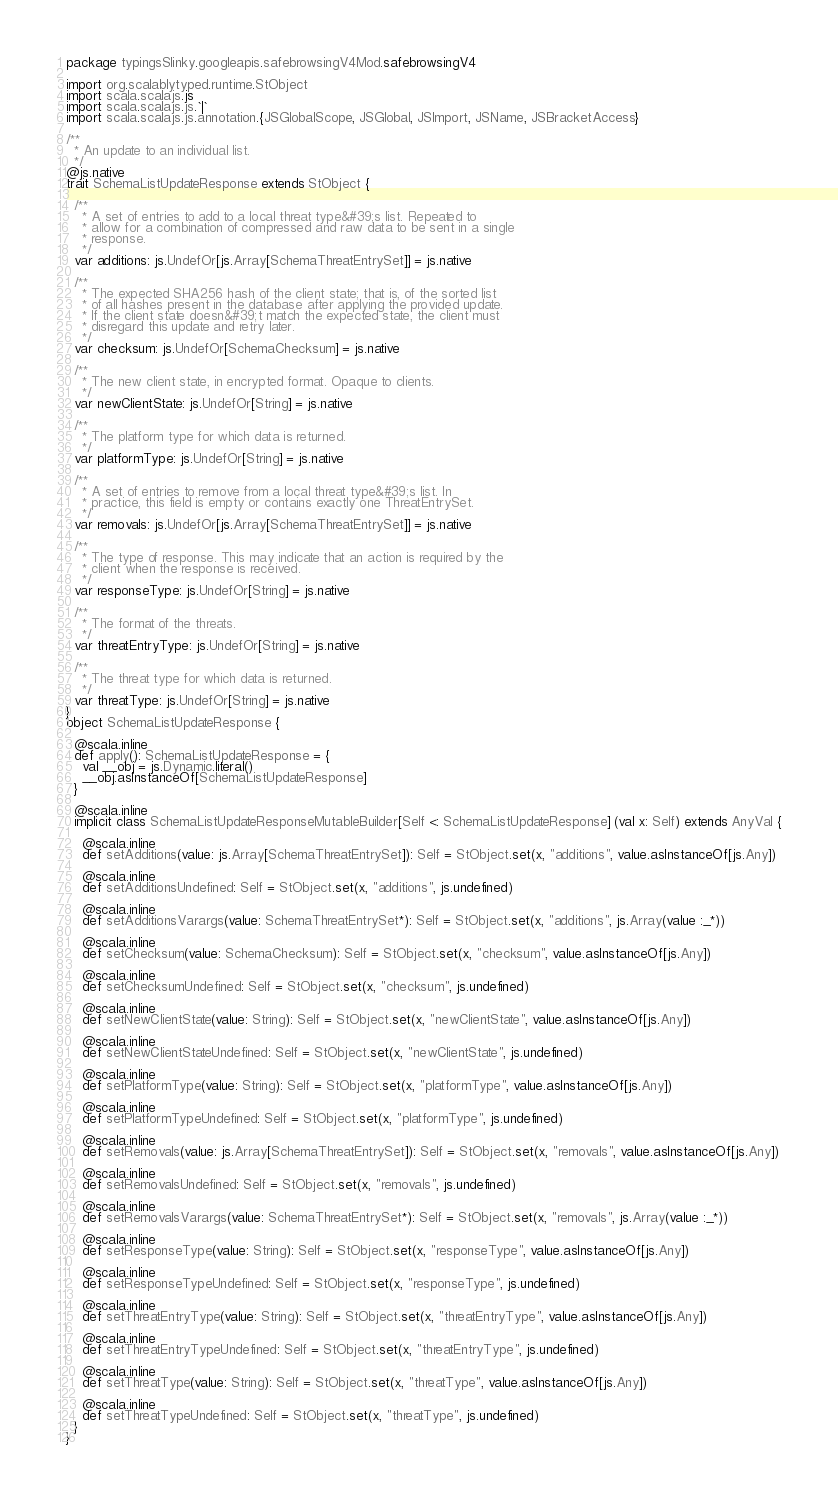<code> <loc_0><loc_0><loc_500><loc_500><_Scala_>package typingsSlinky.googleapis.safebrowsingV4Mod.safebrowsingV4

import org.scalablytyped.runtime.StObject
import scala.scalajs.js
import scala.scalajs.js.`|`
import scala.scalajs.js.annotation.{JSGlobalScope, JSGlobal, JSImport, JSName, JSBracketAccess}

/**
  * An update to an individual list.
  */
@js.native
trait SchemaListUpdateResponse extends StObject {
  
  /**
    * A set of entries to add to a local threat type&#39;s list. Repeated to
    * allow for a combination of compressed and raw data to be sent in a single
    * response.
    */
  var additions: js.UndefOr[js.Array[SchemaThreatEntrySet]] = js.native
  
  /**
    * The expected SHA256 hash of the client state; that is, of the sorted list
    * of all hashes present in the database after applying the provided update.
    * If the client state doesn&#39;t match the expected state, the client must
    * disregard this update and retry later.
    */
  var checksum: js.UndefOr[SchemaChecksum] = js.native
  
  /**
    * The new client state, in encrypted format. Opaque to clients.
    */
  var newClientState: js.UndefOr[String] = js.native
  
  /**
    * The platform type for which data is returned.
    */
  var platformType: js.UndefOr[String] = js.native
  
  /**
    * A set of entries to remove from a local threat type&#39;s list. In
    * practice, this field is empty or contains exactly one ThreatEntrySet.
    */
  var removals: js.UndefOr[js.Array[SchemaThreatEntrySet]] = js.native
  
  /**
    * The type of response. This may indicate that an action is required by the
    * client when the response is received.
    */
  var responseType: js.UndefOr[String] = js.native
  
  /**
    * The format of the threats.
    */
  var threatEntryType: js.UndefOr[String] = js.native
  
  /**
    * The threat type for which data is returned.
    */
  var threatType: js.UndefOr[String] = js.native
}
object SchemaListUpdateResponse {
  
  @scala.inline
  def apply(): SchemaListUpdateResponse = {
    val __obj = js.Dynamic.literal()
    __obj.asInstanceOf[SchemaListUpdateResponse]
  }
  
  @scala.inline
  implicit class SchemaListUpdateResponseMutableBuilder[Self <: SchemaListUpdateResponse] (val x: Self) extends AnyVal {
    
    @scala.inline
    def setAdditions(value: js.Array[SchemaThreatEntrySet]): Self = StObject.set(x, "additions", value.asInstanceOf[js.Any])
    
    @scala.inline
    def setAdditionsUndefined: Self = StObject.set(x, "additions", js.undefined)
    
    @scala.inline
    def setAdditionsVarargs(value: SchemaThreatEntrySet*): Self = StObject.set(x, "additions", js.Array(value :_*))
    
    @scala.inline
    def setChecksum(value: SchemaChecksum): Self = StObject.set(x, "checksum", value.asInstanceOf[js.Any])
    
    @scala.inline
    def setChecksumUndefined: Self = StObject.set(x, "checksum", js.undefined)
    
    @scala.inline
    def setNewClientState(value: String): Self = StObject.set(x, "newClientState", value.asInstanceOf[js.Any])
    
    @scala.inline
    def setNewClientStateUndefined: Self = StObject.set(x, "newClientState", js.undefined)
    
    @scala.inline
    def setPlatformType(value: String): Self = StObject.set(x, "platformType", value.asInstanceOf[js.Any])
    
    @scala.inline
    def setPlatformTypeUndefined: Self = StObject.set(x, "platformType", js.undefined)
    
    @scala.inline
    def setRemovals(value: js.Array[SchemaThreatEntrySet]): Self = StObject.set(x, "removals", value.asInstanceOf[js.Any])
    
    @scala.inline
    def setRemovalsUndefined: Self = StObject.set(x, "removals", js.undefined)
    
    @scala.inline
    def setRemovalsVarargs(value: SchemaThreatEntrySet*): Self = StObject.set(x, "removals", js.Array(value :_*))
    
    @scala.inline
    def setResponseType(value: String): Self = StObject.set(x, "responseType", value.asInstanceOf[js.Any])
    
    @scala.inline
    def setResponseTypeUndefined: Self = StObject.set(x, "responseType", js.undefined)
    
    @scala.inline
    def setThreatEntryType(value: String): Self = StObject.set(x, "threatEntryType", value.asInstanceOf[js.Any])
    
    @scala.inline
    def setThreatEntryTypeUndefined: Self = StObject.set(x, "threatEntryType", js.undefined)
    
    @scala.inline
    def setThreatType(value: String): Self = StObject.set(x, "threatType", value.asInstanceOf[js.Any])
    
    @scala.inline
    def setThreatTypeUndefined: Self = StObject.set(x, "threatType", js.undefined)
  }
}
</code> 